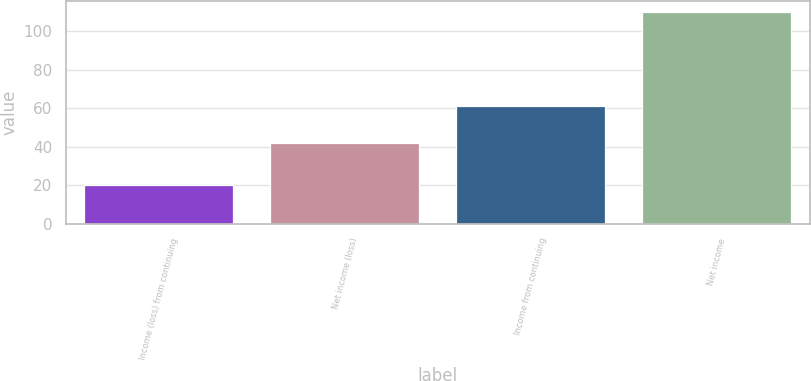Convert chart. <chart><loc_0><loc_0><loc_500><loc_500><bar_chart><fcel>Income (loss) from continuing<fcel>Net income (loss)<fcel>Income from continuing<fcel>Net income<nl><fcel>20<fcel>42<fcel>61<fcel>110<nl></chart> 